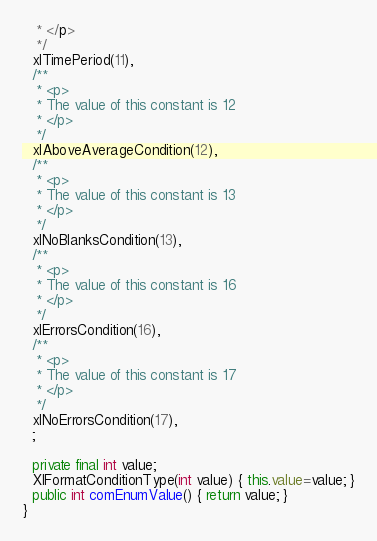<code> <loc_0><loc_0><loc_500><loc_500><_Java_>   * </p>
   */
  xlTimePeriod(11),
  /**
   * <p>
   * The value of this constant is 12
   * </p>
   */
  xlAboveAverageCondition(12),
  /**
   * <p>
   * The value of this constant is 13
   * </p>
   */
  xlNoBlanksCondition(13),
  /**
   * <p>
   * The value of this constant is 16
   * </p>
   */
  xlErrorsCondition(16),
  /**
   * <p>
   * The value of this constant is 17
   * </p>
   */
  xlNoErrorsCondition(17),
  ;

  private final int value;
  XlFormatConditionType(int value) { this.value=value; }
  public int comEnumValue() { return value; }
}
</code> 